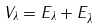<formula> <loc_0><loc_0><loc_500><loc_500>V _ { \lambda } = E _ { \lambda } + E _ { \bar { \lambda } }</formula> 